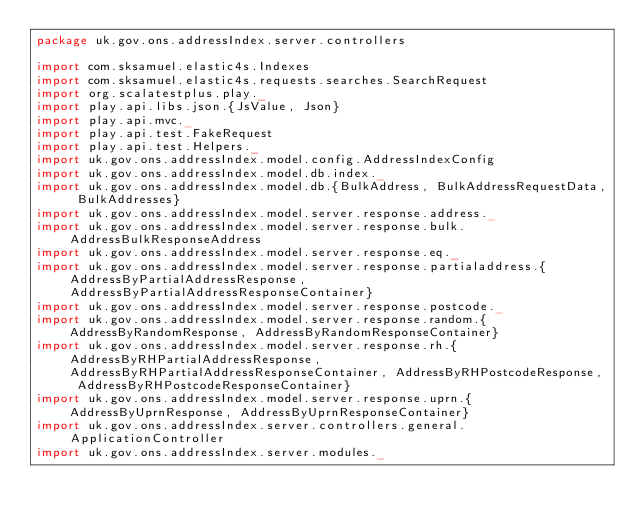Convert code to text. <code><loc_0><loc_0><loc_500><loc_500><_Scala_>package uk.gov.ons.addressIndex.server.controllers

import com.sksamuel.elastic4s.Indexes
import com.sksamuel.elastic4s.requests.searches.SearchRequest
import org.scalatestplus.play._
import play.api.libs.json.{JsValue, Json}
import play.api.mvc._
import play.api.test.FakeRequest
import play.api.test.Helpers._
import uk.gov.ons.addressIndex.model.config.AddressIndexConfig
import uk.gov.ons.addressIndex.model.db.index._
import uk.gov.ons.addressIndex.model.db.{BulkAddress, BulkAddressRequestData, BulkAddresses}
import uk.gov.ons.addressIndex.model.server.response.address._
import uk.gov.ons.addressIndex.model.server.response.bulk.AddressBulkResponseAddress
import uk.gov.ons.addressIndex.model.server.response.eq._
import uk.gov.ons.addressIndex.model.server.response.partialaddress.{AddressByPartialAddressResponse, AddressByPartialAddressResponseContainer}
import uk.gov.ons.addressIndex.model.server.response.postcode._
import uk.gov.ons.addressIndex.model.server.response.random.{AddressByRandomResponse, AddressByRandomResponseContainer}
import uk.gov.ons.addressIndex.model.server.response.rh.{AddressByRHPartialAddressResponse, AddressByRHPartialAddressResponseContainer, AddressByRHPostcodeResponse, AddressByRHPostcodeResponseContainer}
import uk.gov.ons.addressIndex.model.server.response.uprn.{AddressByUprnResponse, AddressByUprnResponseContainer}
import uk.gov.ons.addressIndex.server.controllers.general.ApplicationController
import uk.gov.ons.addressIndex.server.modules._</code> 